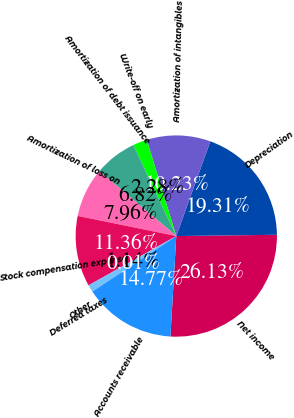Convert chart to OTSL. <chart><loc_0><loc_0><loc_500><loc_500><pie_chart><fcel>Net income<fcel>Depreciation<fcel>Amortization of intangibles<fcel>Write-off on early<fcel>Amortization of debt issuance<fcel>Amortization of loss on<fcel>Stock compensation expense<fcel>Deferred taxes<fcel>Other<fcel>Accounts receivable<nl><fcel>26.13%<fcel>19.31%<fcel>10.23%<fcel>2.28%<fcel>6.82%<fcel>7.96%<fcel>11.36%<fcel>1.14%<fcel>0.01%<fcel>14.77%<nl></chart> 